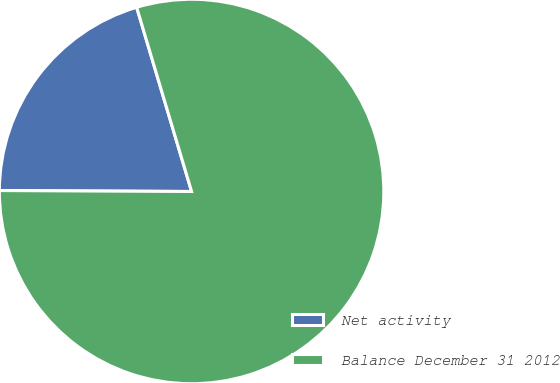<chart> <loc_0><loc_0><loc_500><loc_500><pie_chart><fcel>Net activity<fcel>Balance December 31 2012<nl><fcel>20.31%<fcel>79.69%<nl></chart> 